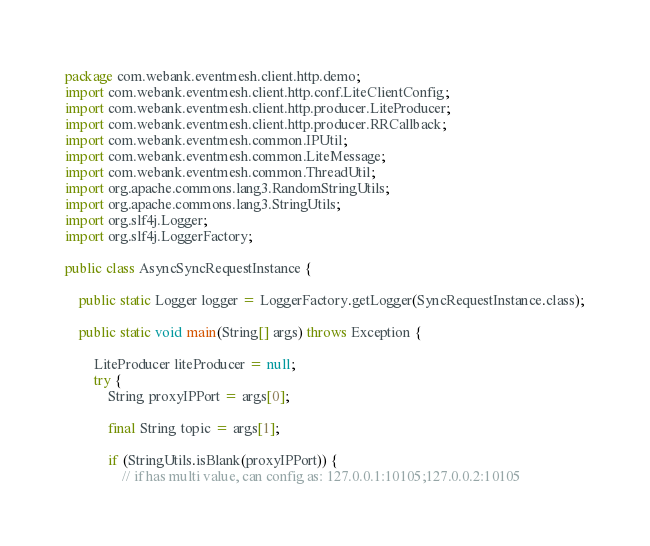<code> <loc_0><loc_0><loc_500><loc_500><_Java_>package com.webank.eventmesh.client.http.demo;
import com.webank.eventmesh.client.http.conf.LiteClientConfig;
import com.webank.eventmesh.client.http.producer.LiteProducer;
import com.webank.eventmesh.client.http.producer.RRCallback;
import com.webank.eventmesh.common.IPUtil;
import com.webank.eventmesh.common.LiteMessage;
import com.webank.eventmesh.common.ThreadUtil;
import org.apache.commons.lang3.RandomStringUtils;
import org.apache.commons.lang3.StringUtils;
import org.slf4j.Logger;
import org.slf4j.LoggerFactory;

public class AsyncSyncRequestInstance {

    public static Logger logger = LoggerFactory.getLogger(SyncRequestInstance.class);

    public static void main(String[] args) throws Exception {

        LiteProducer liteProducer = null;
        try {
            String proxyIPPort = args[0];

            final String topic = args[1];

            if (StringUtils.isBlank(proxyIPPort)) {
                // if has multi value, can config as: 127.0.0.1:10105;127.0.0.2:10105</code> 